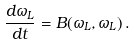Convert formula to latex. <formula><loc_0><loc_0><loc_500><loc_500>\frac { d \omega _ { L } } { d t } = B ( \omega _ { L } , \omega _ { L } ) \, .</formula> 